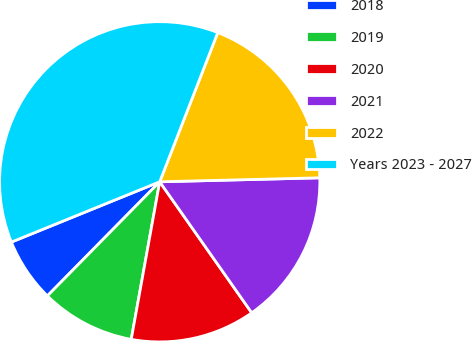Convert chart. <chart><loc_0><loc_0><loc_500><loc_500><pie_chart><fcel>2018<fcel>2019<fcel>2020<fcel>2021<fcel>2022<fcel>Years 2023 - 2027<nl><fcel>6.48%<fcel>9.53%<fcel>12.59%<fcel>15.65%<fcel>18.7%<fcel>37.05%<nl></chart> 